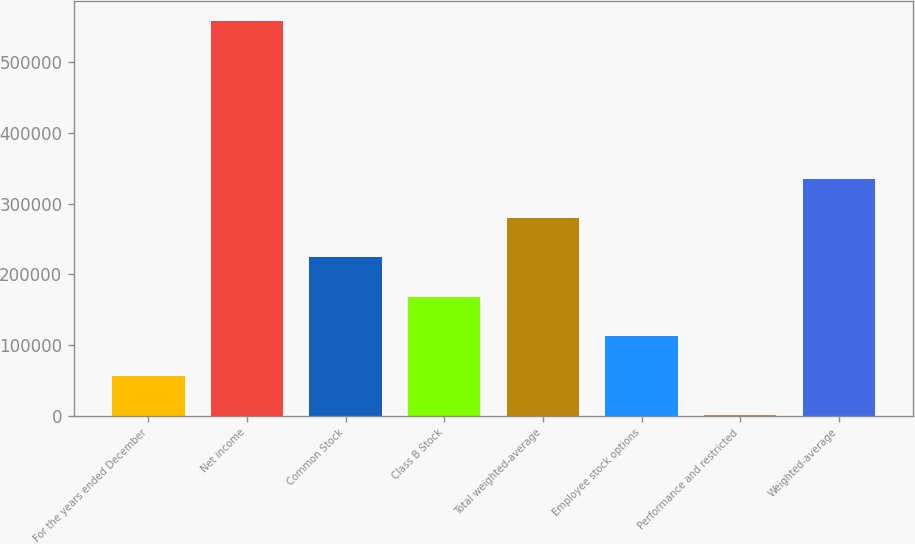<chart> <loc_0><loc_0><loc_500><loc_500><bar_chart><fcel>For the years ended December<fcel>Net income<fcel>Common Stock<fcel>Class B Stock<fcel>Total weighted-average<fcel>Employee stock options<fcel>Performance and restricted<fcel>Weighted-average<nl><fcel>56579.3<fcel>559061<fcel>224073<fcel>168242<fcel>279904<fcel>112411<fcel>748<fcel>335736<nl></chart> 